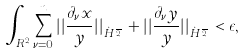Convert formula to latex. <formula><loc_0><loc_0><loc_500><loc_500>\int _ { { R } ^ { 2 } } \sum _ { \nu = 0 } ^ { n } | | \frac { \partial _ { \nu } { x } } { y } | | _ { \dot { H } ^ { \frac { n } { 2 } } } + | | \frac { \partial _ { \nu } { y } } { y } | | _ { \dot { H } ^ { \frac { n } { 2 } } } < \epsilon ,</formula> 